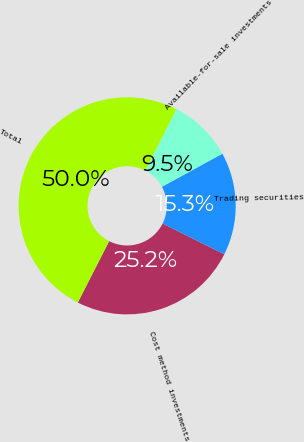Convert chart to OTSL. <chart><loc_0><loc_0><loc_500><loc_500><pie_chart><fcel>Cost method investments<fcel>Trading securities<fcel>Available-for-sale investments<fcel>Total<nl><fcel>25.15%<fcel>15.34%<fcel>9.51%<fcel>50.0%<nl></chart> 